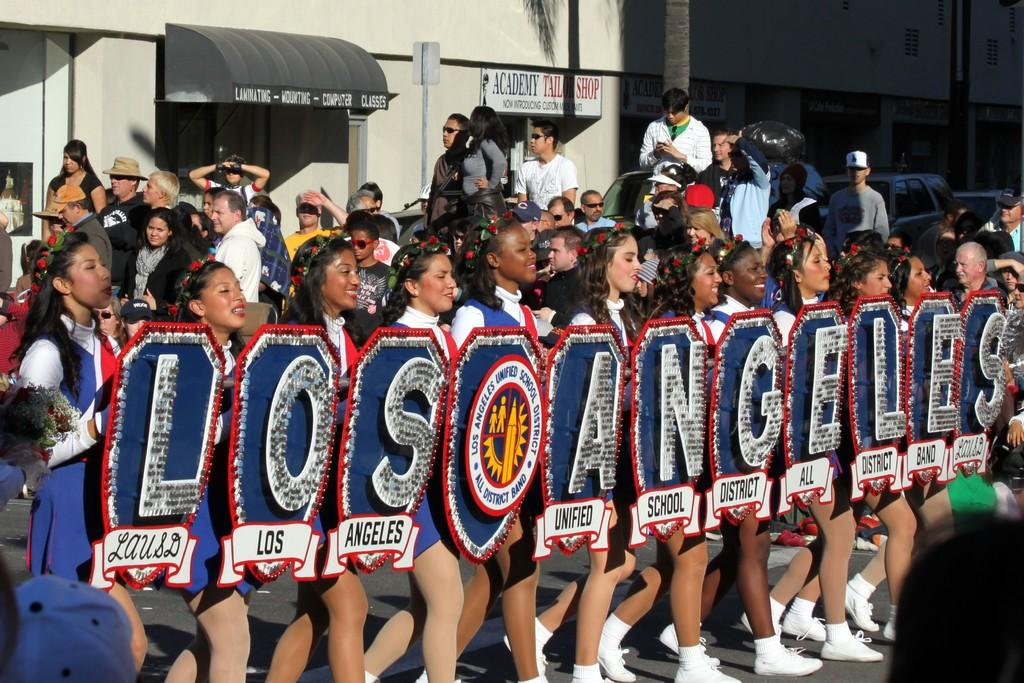<image>
Give a short and clear explanation of the subsequent image. a line of cheerleaders holding up a LOS ANGELES team banner 